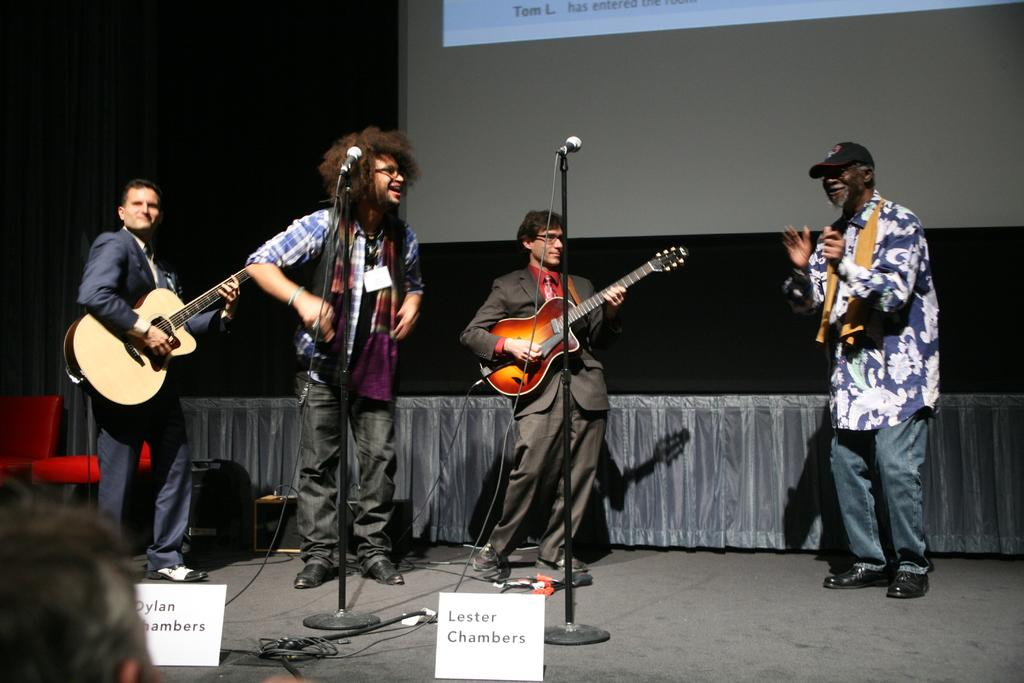How many people are in the image? There are four persons in the image. What are the persons doing in the image? The persons are playing guitar. Where are the persons standing in the image? The persons are standing on the floor. What can be seen in the background of the image? There is a curtain and a screen in the background of the image. Is there any furniture in the image? Yes, there is a chair in the image. What historical event is being commemorated by the team in the image? There is no team or historical event present in the image; it features four persons playing guitar. How many soldiers are visible in the image? There are no soldiers or army-related elements present in the image. 